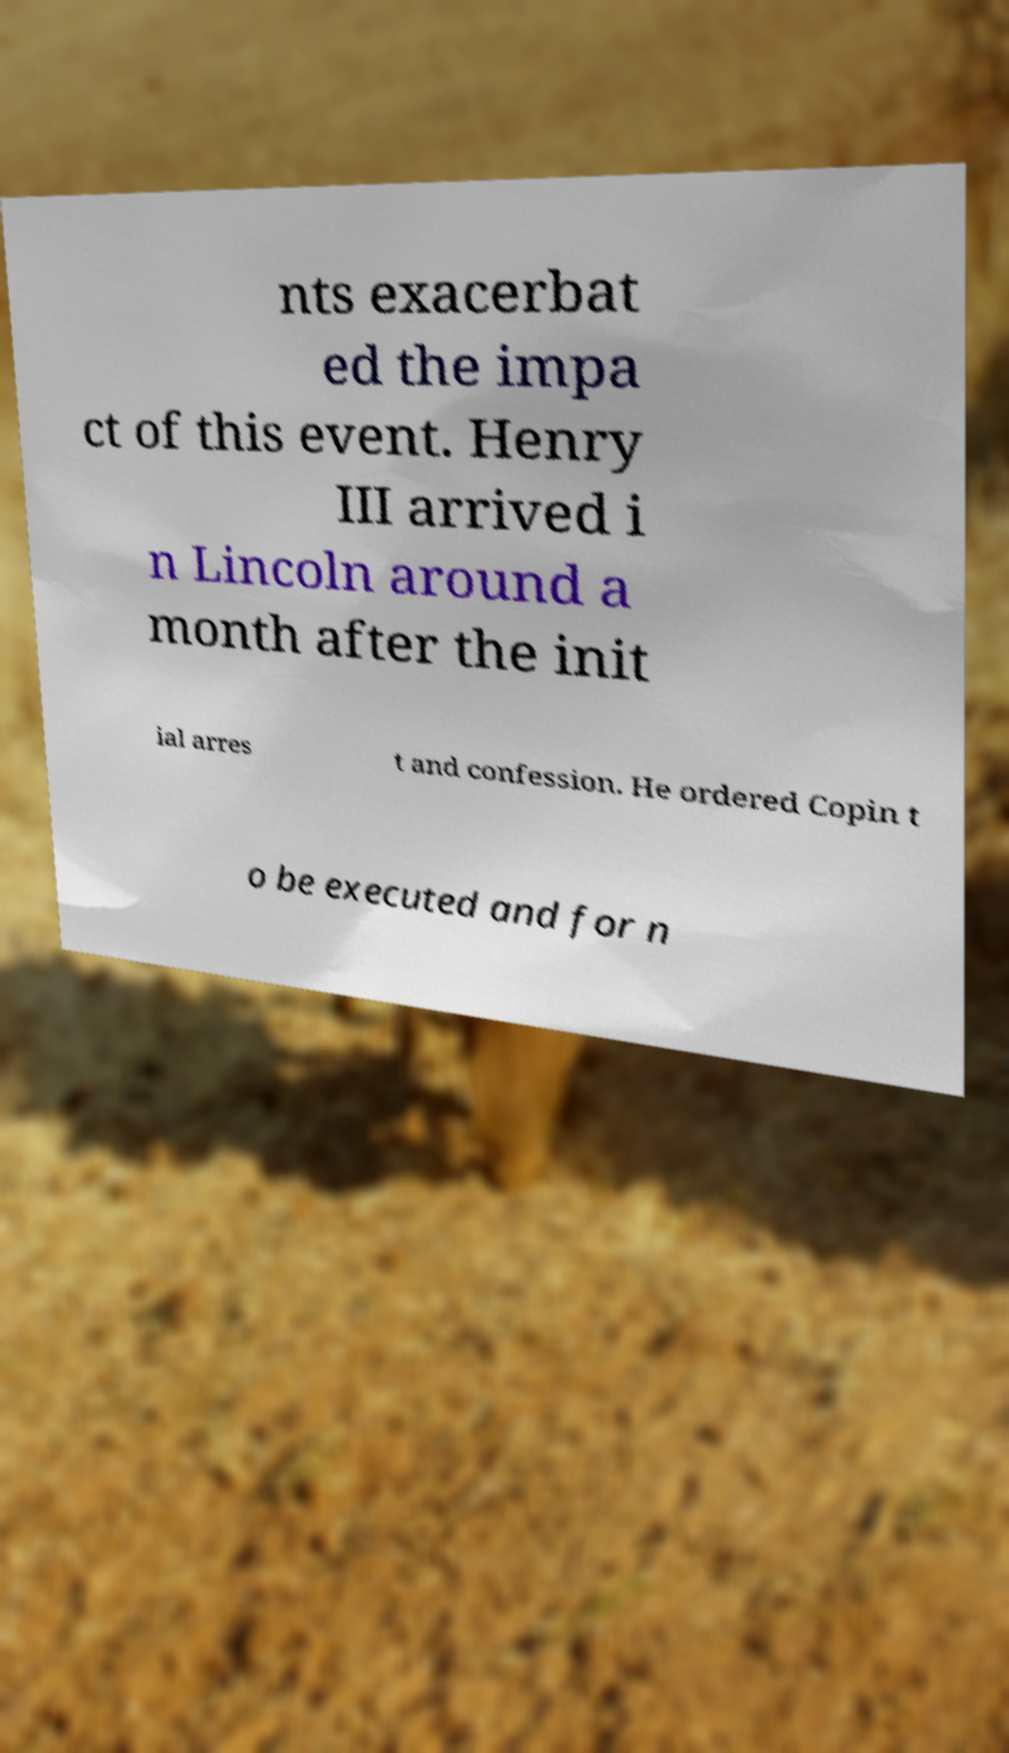What messages or text are displayed in this image? I need them in a readable, typed format. nts exacerbat ed the impa ct of this event. Henry III arrived i n Lincoln around a month after the init ial arres t and confession. He ordered Copin t o be executed and for n 